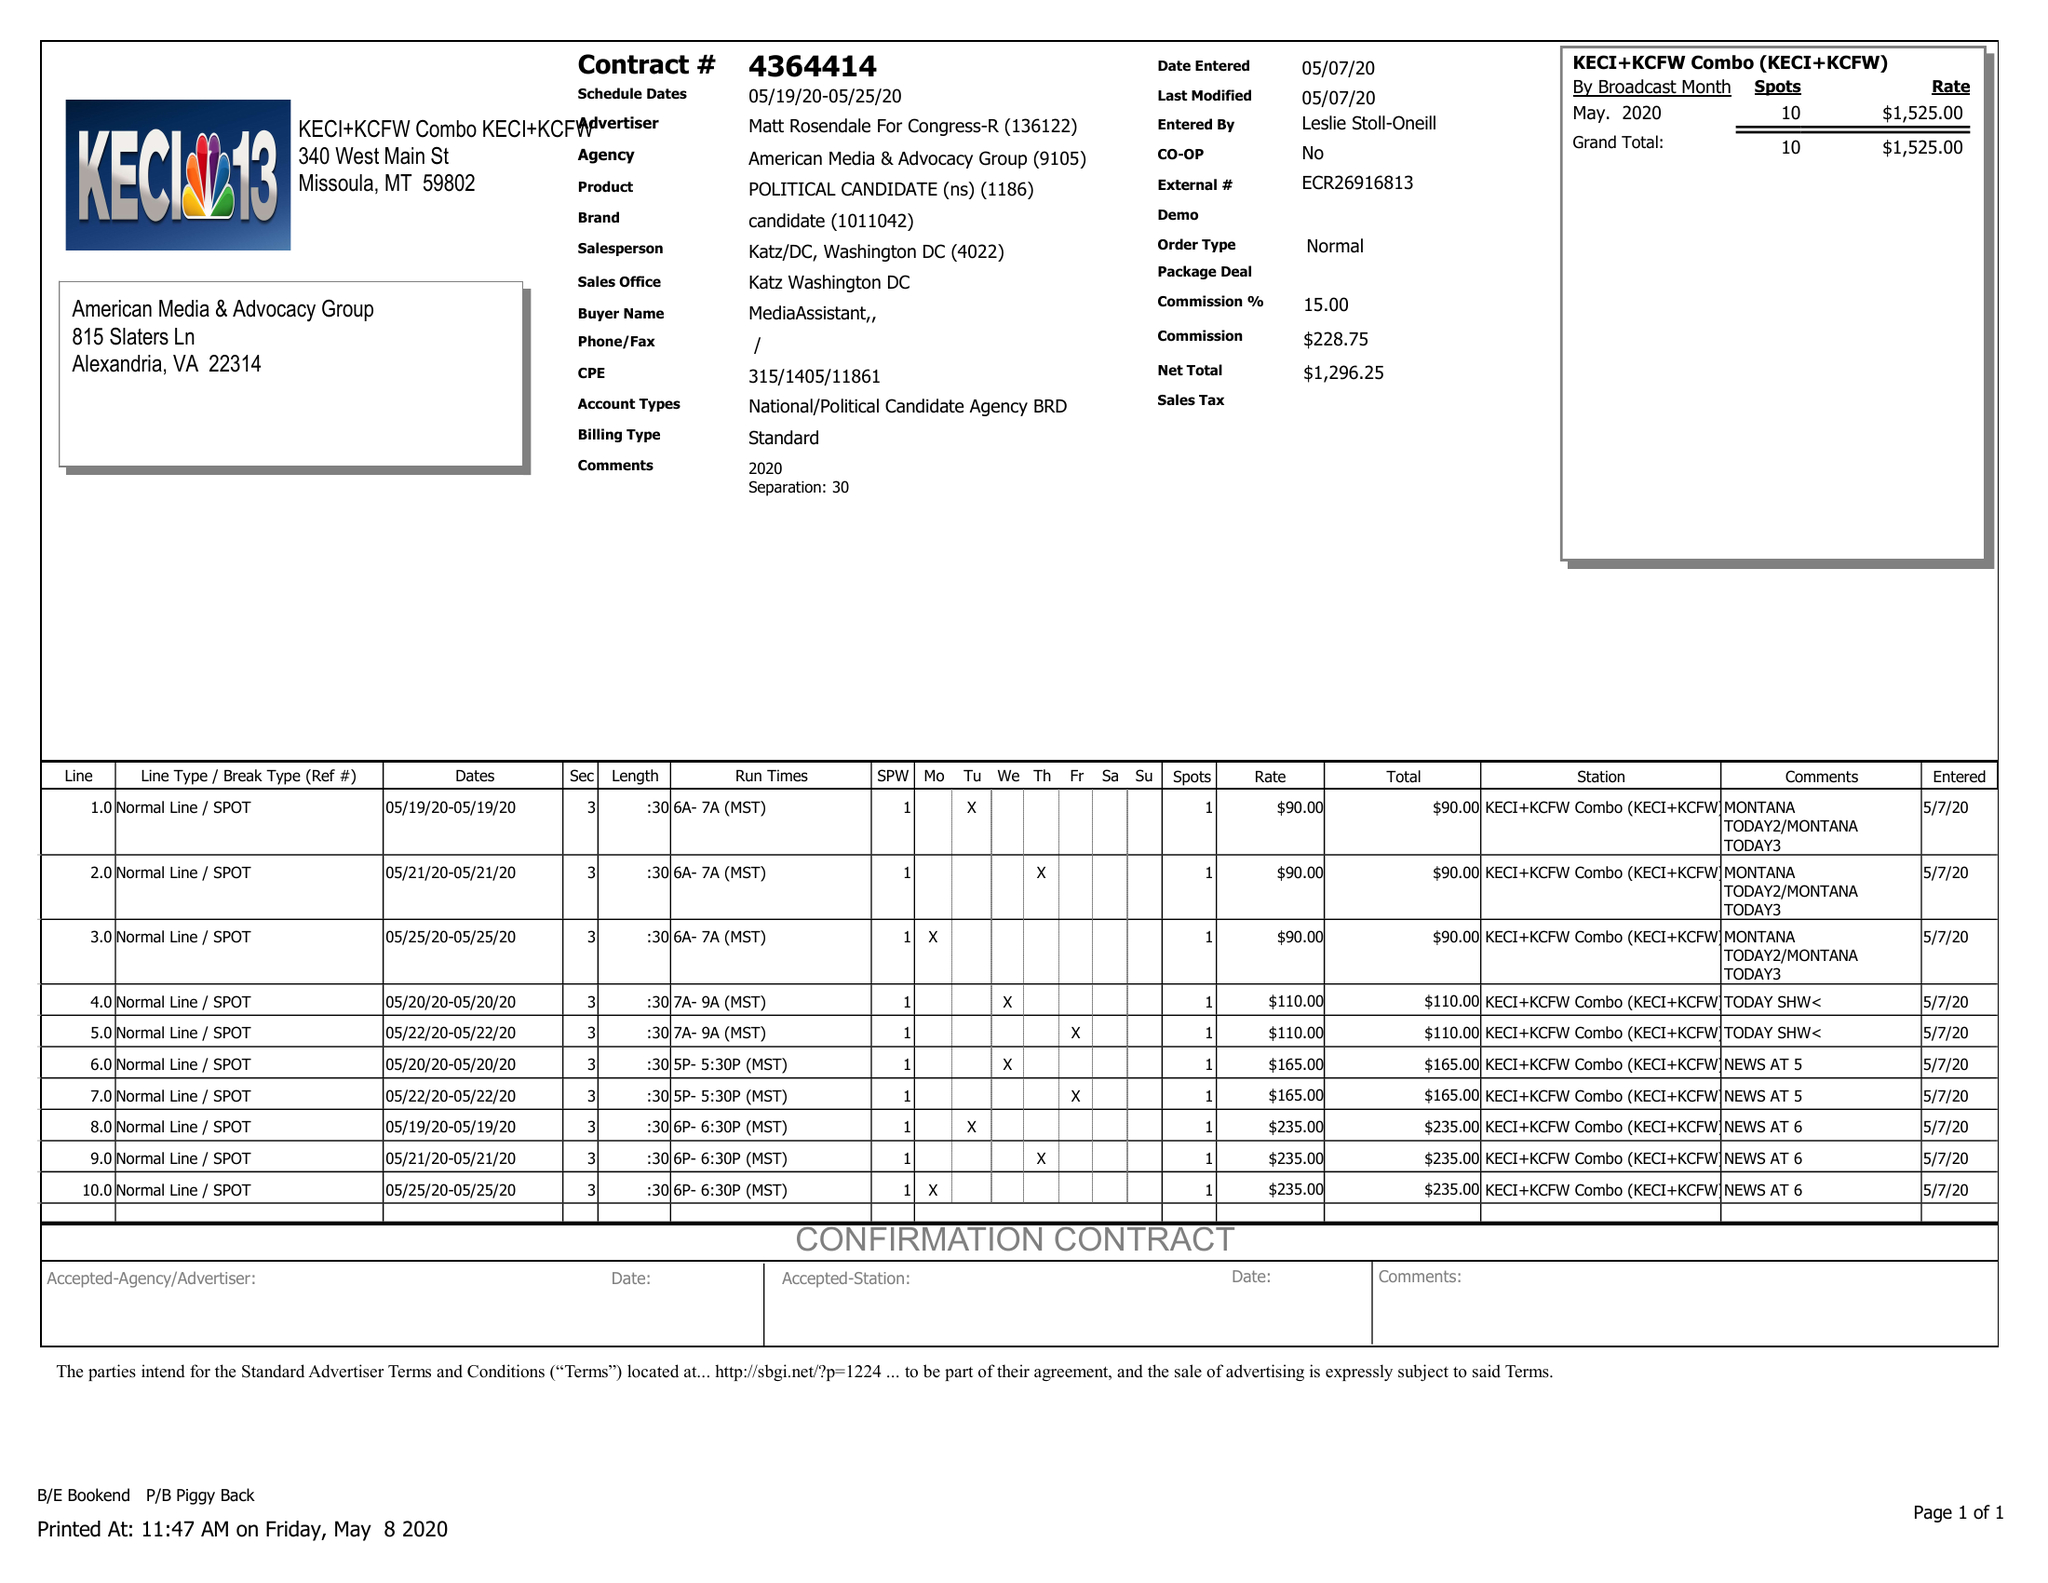What is the value for the gross_amount?
Answer the question using a single word or phrase. 1525.00 